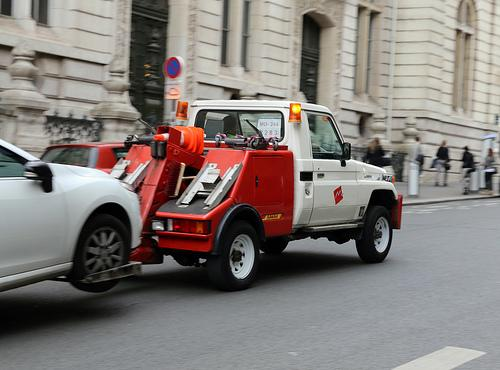What is the color of the hair of the person with blond hair? The hair color is blond. Which vehicle is doing most of the action in this image, and what is it doing? A tow truck is driving on the street, towing a damaged white car. Identify the color and type of the sign near the top-left corner of the image. The sign is a blue and red stop sign. Explain the appearance of the building in the image. The building has white stones, a door, and two thin windows near the top. Describe the scene involving the people in the image. Several people are walking on the pavement and the street, with some on the sidewalk and others crossing the street. Mention something notable about a crane in the image. A part of the crane is red. What is happening with the white car in the image? The white car is damaged and is being towed by a tow truck. What kind of obstacles are placed on the street in this image? Several orange cones are placed on the street. What can be seen on the side of the door in the middle of the image? There is a red logo on the side of the door. Describe the function of the object with light on the side of the car. The light on the side of the car serves as a visibility and safety feature. 